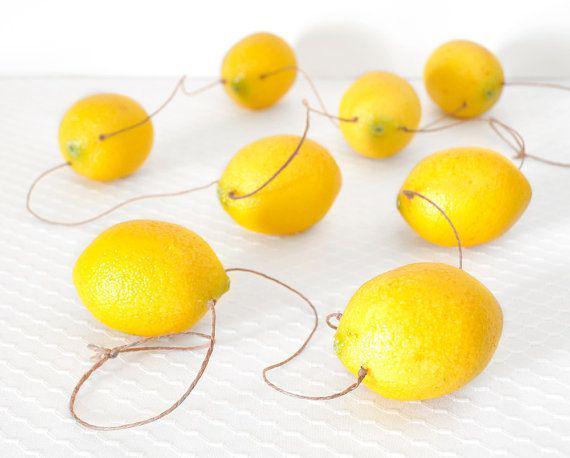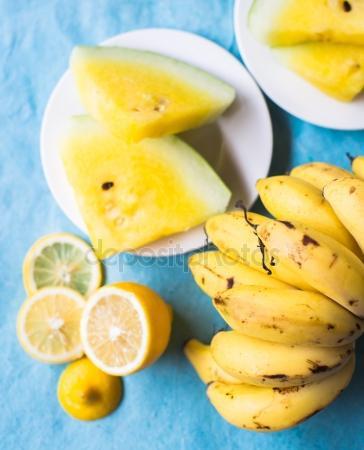The first image is the image on the left, the second image is the image on the right. Assess this claim about the two images: "An image shows glasses garnished with green leaves and watermelon slices.". Correct or not? Answer yes or no. No. The first image is the image on the left, the second image is the image on the right. Examine the images to the left and right. Is the description "Watermelon slices are pictured with lemons." accurate? Answer yes or no. No. 